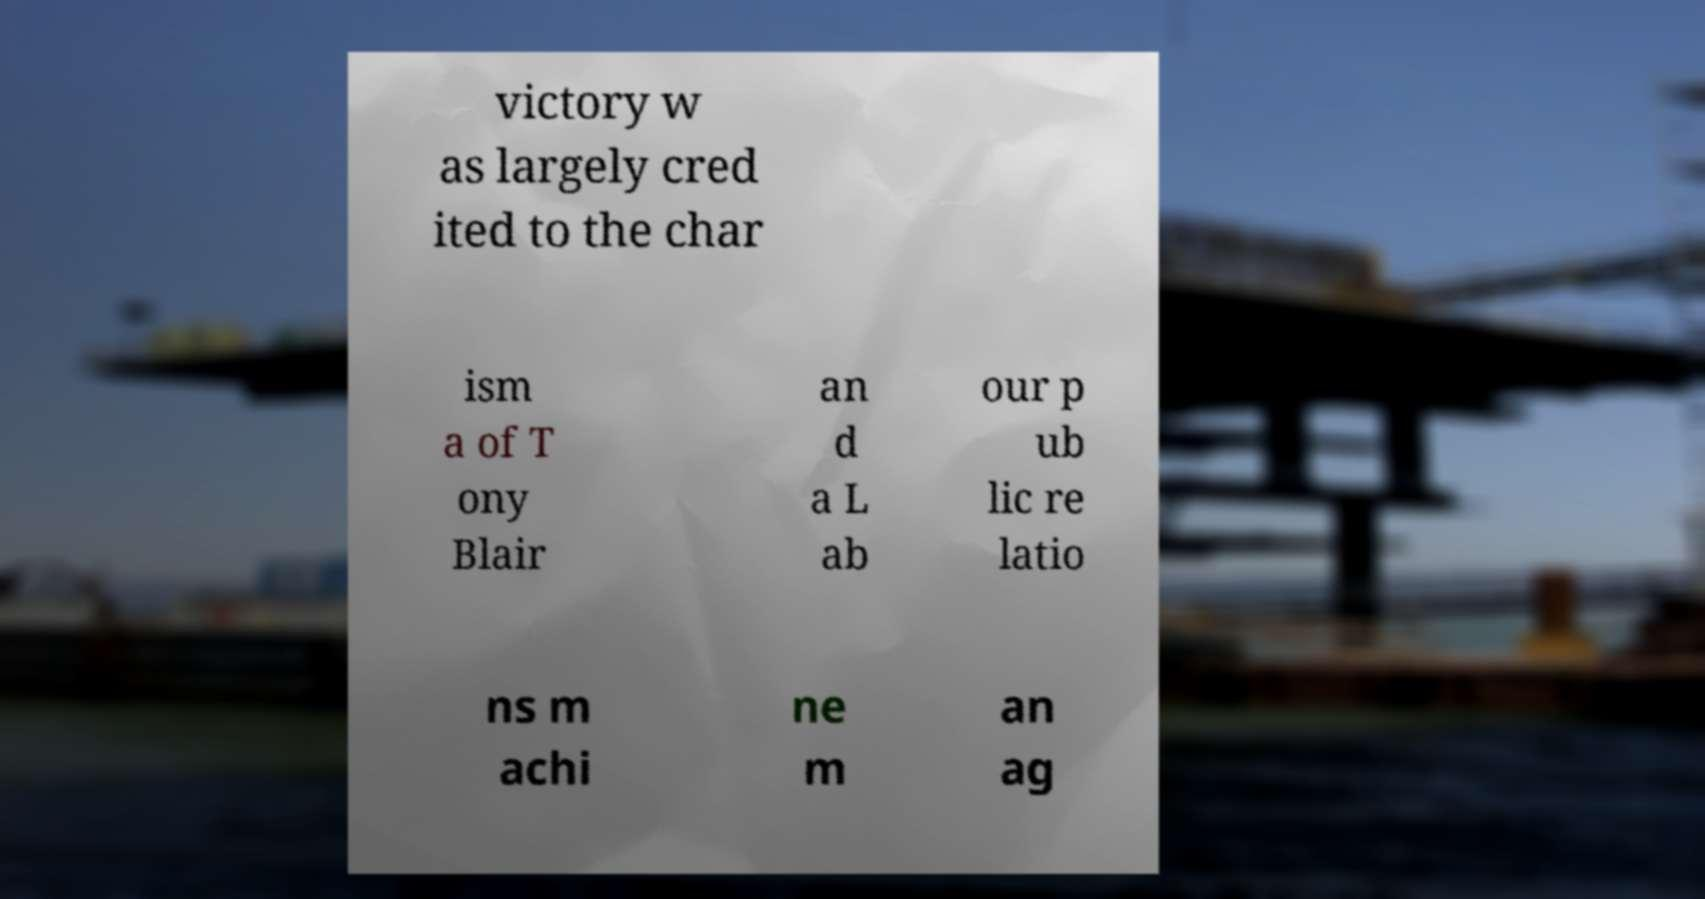For documentation purposes, I need the text within this image transcribed. Could you provide that? victory w as largely cred ited to the char ism a of T ony Blair an d a L ab our p ub lic re latio ns m achi ne m an ag 